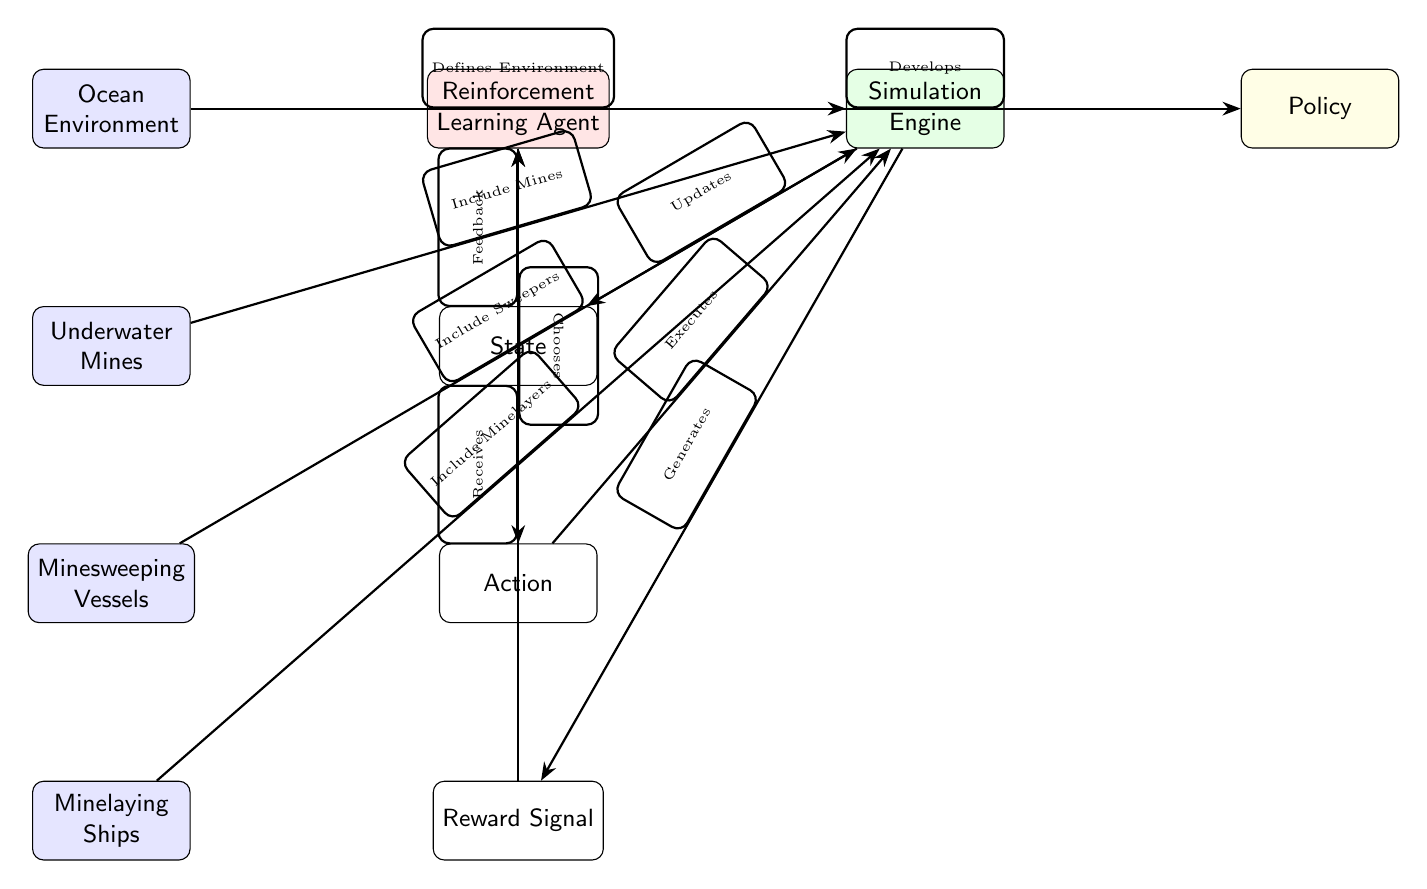What is the top node in the diagram? The top node in the diagram is "Ocean Environment," which is the starting point of the flowchart representing the entire scenario.
Answer: Ocean Environment How many nodes are in the left section? In the left section of the diagram, there are four nodes: Ocean Environment, Underwater Mines, Minesweeping Vessels, and Minelaying Ships.
Answer: 4 Which node generates the reward? The "Simulation Engine" node is responsible for generating the reward signal based on the actions executed in the simulation environment.
Answer: Simulation Engine What action does the RL agent take after receiving the reward signal? After receiving the reward signal, the RL Agent updates its policy, which guides future decisions and actions in the environment.
Answer: Develops What is the relationship between the Minesweeping Vessels and the Simulation Engine? The Minesweeping Vessels node contributes to the definition of the simulation environment, which is essential for modeling minesweeping strategies effectively.
Answer: Include Sweepers What does the RL agent receive from the reward signal? The RL agent receives feedback based on the actions taken in the environment, which is crucial for learning and improving its decision-making abilities.
Answer: Receives How many edges are there connecting the RL Agent to the Simulation Engine? The RL Agent has two direct edges connecting it to the Simulation Engine: one for choosing the action and another for developing the policy.
Answer: 2 Which node does the state arrow point to from the Simulation Engine? The state arrow from the Simulation Engine points back to the RL Agent, indicating that the updated state provides information for the agent's next action decision process.
Answer: RL Agent Which node includes the Underwater Mines? The "Simulation Engine" includes the Underwater Mines as part of the environment it models for the reinforcement learning process.
Answer: Simulation Engine 